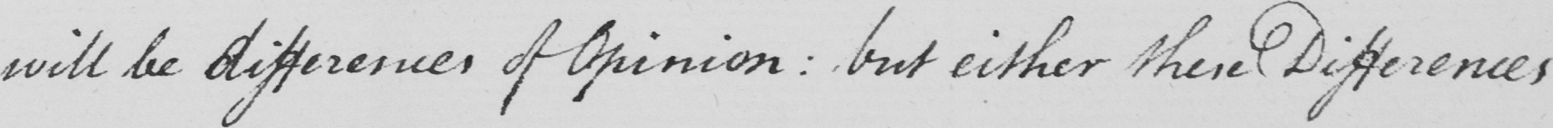What does this handwritten line say? will be differences of opinion :  but either their Differences 